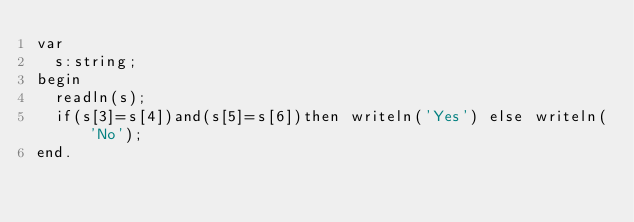<code> <loc_0><loc_0><loc_500><loc_500><_Pascal_>var
  s:string;
begin
  readln(s);
  if(s[3]=s[4])and(s[5]=s[6])then writeln('Yes') else writeln('No');
end.</code> 